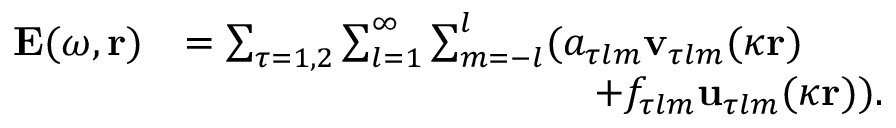<formula> <loc_0><loc_0><loc_500><loc_500>\begin{array} { r l } { E ( \omega , r ) } & { = \sum _ { \tau = 1 , 2 } \sum _ { l = 1 } ^ { \infty } \sum _ { m = - l } ^ { l } ( a _ { \tau l m } v _ { \tau l m } ( \kappa r ) } \\ & { \quad + f _ { \tau l m } u _ { \tau l m } ( \kappa r ) ) . } \end{array}</formula> 